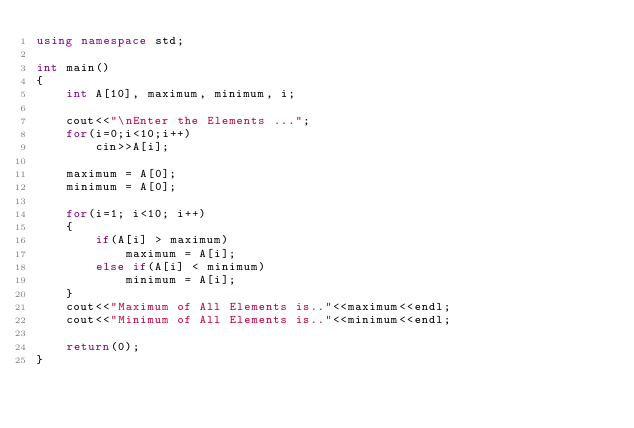<code> <loc_0><loc_0><loc_500><loc_500><_C++_>using namespace std;

int main()
{
    int A[10], maximum, minimum, i;

    cout<<"\nEnter the Elements ...";
    for(i=0;i<10;i++)
        cin>>A[i];

    maximum = A[0];
    minimum = A[0];

    for(i=1; i<10; i++)
    {
        if(A[i] > maximum)
            maximum = A[i];
        else if(A[i] < minimum)
            minimum = A[i];
    }
    cout<<"Maximum of All Elements is.."<<maximum<<endl;
    cout<<"Minimum of All Elements is.."<<minimum<<endl;

    return(0);
}</code> 